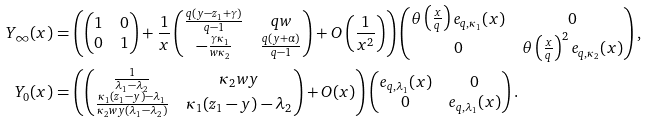Convert formula to latex. <formula><loc_0><loc_0><loc_500><loc_500>Y _ { \infty } ( x ) & = \left ( \begin{pmatrix} 1 & 0 \\ 0 & 1 \end{pmatrix} + \frac { 1 } { x } \begin{pmatrix} \frac { q \left ( y - z _ { 1 } + \gamma \right ) } { q - 1 } & q w \\ - \frac { \gamma \kappa _ { 1 } } { w \kappa _ { 2 } } & \frac { q ( y + \alpha ) } { q - 1 } \end{pmatrix} + O \left ( \frac { 1 } { x ^ { 2 } } \right ) \right ) \begin{pmatrix} \theta \left ( \frac { x } { q } \right ) e _ { q , \kappa _ { 1 } } ( x ) & 0 \\ 0 & \theta \left ( \frac { x } { q } \right ) ^ { 2 } e _ { q , \kappa _ { 2 } } ( x ) \end{pmatrix} , \\ Y _ { 0 } ( x ) & = \left ( \begin{pmatrix} \frac { 1 } { \lambda _ { 1 } - \lambda _ { 2 } } & \kappa _ { 2 } w y \\ \frac { \kappa _ { 1 } ( z _ { 1 } - y ) - \lambda _ { 1 } } { \kappa _ { 2 } w y ( \lambda _ { 1 } - \lambda _ { 2 } ) } & \kappa _ { 1 } ( z _ { 1 } - y ) - \lambda _ { 2 } \end{pmatrix} + O ( x ) \right ) \begin{pmatrix} e _ { q , \lambda _ { 1 } } ( x ) & 0 \\ 0 & e _ { q , \lambda _ { 1 } } ( x ) \end{pmatrix} .</formula> 